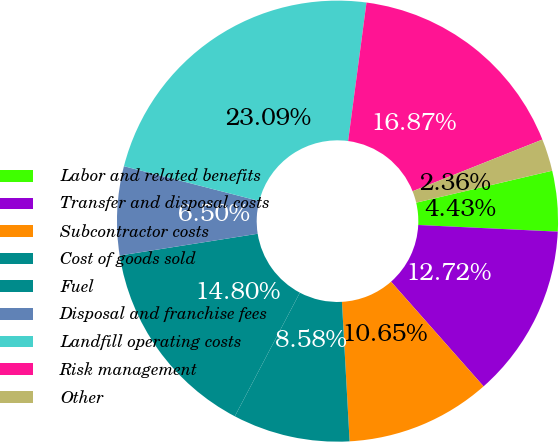Convert chart. <chart><loc_0><loc_0><loc_500><loc_500><pie_chart><fcel>Labor and related benefits<fcel>Transfer and disposal costs<fcel>Subcontractor costs<fcel>Cost of goods sold<fcel>Fuel<fcel>Disposal and franchise fees<fcel>Landfill operating costs<fcel>Risk management<fcel>Other<nl><fcel>4.43%<fcel>12.72%<fcel>10.65%<fcel>8.58%<fcel>14.8%<fcel>6.5%<fcel>23.09%<fcel>16.87%<fcel>2.36%<nl></chart> 